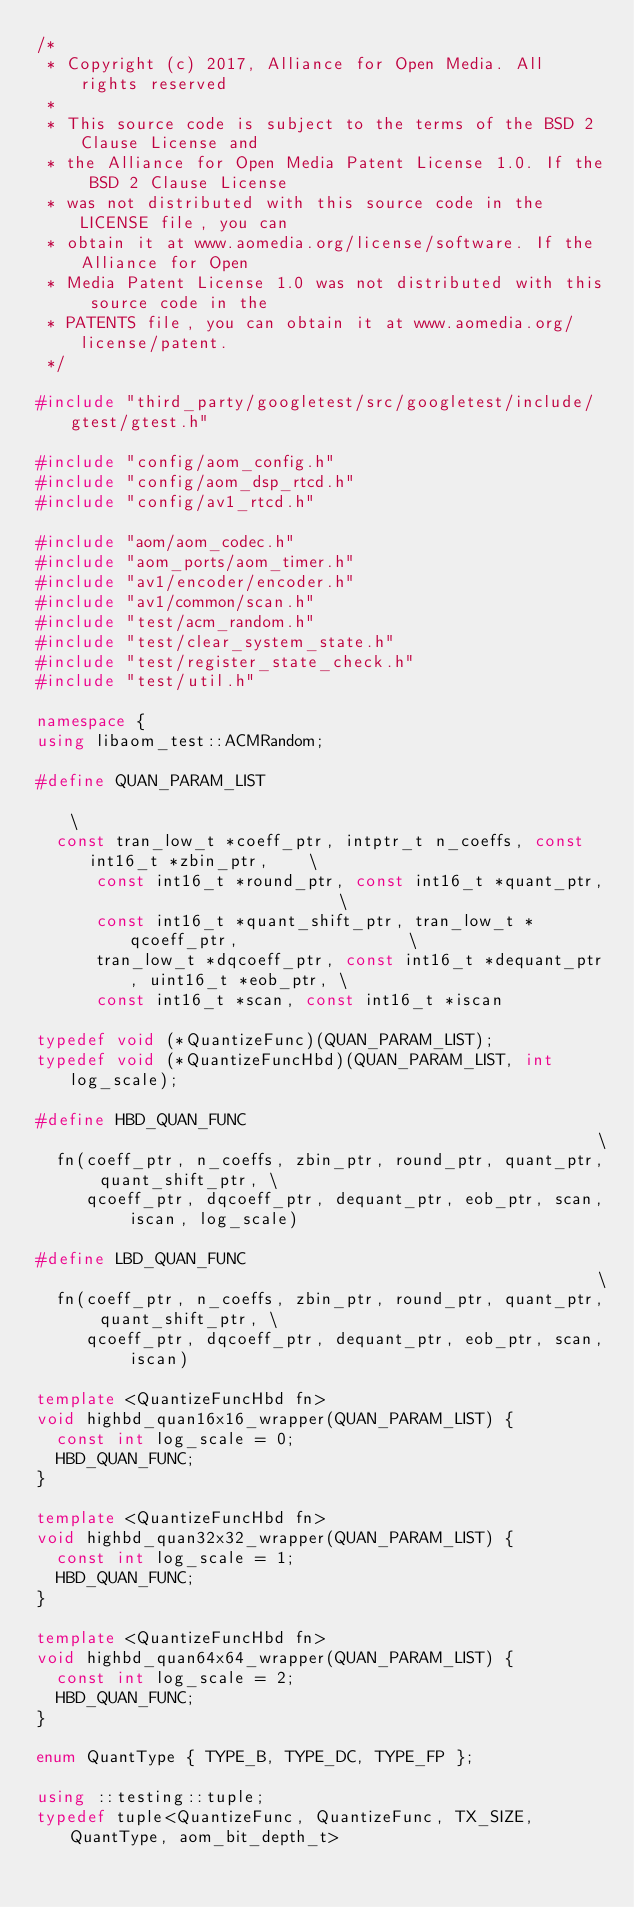<code> <loc_0><loc_0><loc_500><loc_500><_C++_>/*
 * Copyright (c) 2017, Alliance for Open Media. All rights reserved
 *
 * This source code is subject to the terms of the BSD 2 Clause License and
 * the Alliance for Open Media Patent License 1.0. If the BSD 2 Clause License
 * was not distributed with this source code in the LICENSE file, you can
 * obtain it at www.aomedia.org/license/software. If the Alliance for Open
 * Media Patent License 1.0 was not distributed with this source code in the
 * PATENTS file, you can obtain it at www.aomedia.org/license/patent.
 */

#include "third_party/googletest/src/googletest/include/gtest/gtest.h"

#include "config/aom_config.h"
#include "config/aom_dsp_rtcd.h"
#include "config/av1_rtcd.h"

#include "aom/aom_codec.h"
#include "aom_ports/aom_timer.h"
#include "av1/encoder/encoder.h"
#include "av1/common/scan.h"
#include "test/acm_random.h"
#include "test/clear_system_state.h"
#include "test/register_state_check.h"
#include "test/util.h"

namespace {
using libaom_test::ACMRandom;

#define QUAN_PARAM_LIST                                                       \
  const tran_low_t *coeff_ptr, intptr_t n_coeffs, const int16_t *zbin_ptr,    \
      const int16_t *round_ptr, const int16_t *quant_ptr,                     \
      const int16_t *quant_shift_ptr, tran_low_t *qcoeff_ptr,                 \
      tran_low_t *dqcoeff_ptr, const int16_t *dequant_ptr, uint16_t *eob_ptr, \
      const int16_t *scan, const int16_t *iscan

typedef void (*QuantizeFunc)(QUAN_PARAM_LIST);
typedef void (*QuantizeFuncHbd)(QUAN_PARAM_LIST, int log_scale);

#define HBD_QUAN_FUNC                                                      \
  fn(coeff_ptr, n_coeffs, zbin_ptr, round_ptr, quant_ptr, quant_shift_ptr, \
     qcoeff_ptr, dqcoeff_ptr, dequant_ptr, eob_ptr, scan, iscan, log_scale)

#define LBD_QUAN_FUNC                                                      \
  fn(coeff_ptr, n_coeffs, zbin_ptr, round_ptr, quant_ptr, quant_shift_ptr, \
     qcoeff_ptr, dqcoeff_ptr, dequant_ptr, eob_ptr, scan, iscan)

template <QuantizeFuncHbd fn>
void highbd_quan16x16_wrapper(QUAN_PARAM_LIST) {
  const int log_scale = 0;
  HBD_QUAN_FUNC;
}

template <QuantizeFuncHbd fn>
void highbd_quan32x32_wrapper(QUAN_PARAM_LIST) {
  const int log_scale = 1;
  HBD_QUAN_FUNC;
}

template <QuantizeFuncHbd fn>
void highbd_quan64x64_wrapper(QUAN_PARAM_LIST) {
  const int log_scale = 2;
  HBD_QUAN_FUNC;
}

enum QuantType { TYPE_B, TYPE_DC, TYPE_FP };

using ::testing::tuple;
typedef tuple<QuantizeFunc, QuantizeFunc, TX_SIZE, QuantType, aom_bit_depth_t></code> 